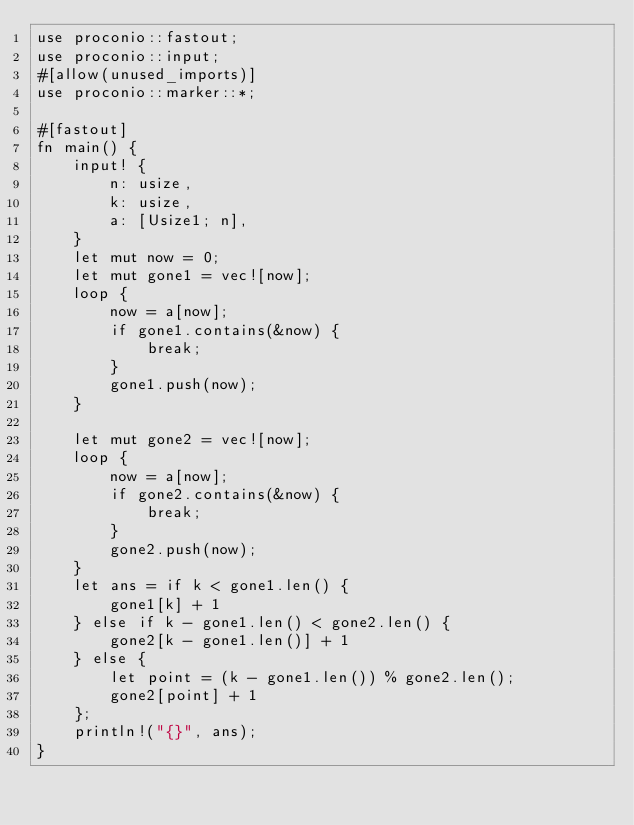<code> <loc_0><loc_0><loc_500><loc_500><_Rust_>use proconio::fastout;
use proconio::input;
#[allow(unused_imports)]
use proconio::marker::*;

#[fastout]
fn main() {
    input! {
        n: usize,
        k: usize,
        a: [Usize1; n],
    }
    let mut now = 0;
    let mut gone1 = vec![now];
    loop {
        now = a[now];
        if gone1.contains(&now) {
            break;
        }
        gone1.push(now);
    }

    let mut gone2 = vec![now];
    loop {
        now = a[now];
        if gone2.contains(&now) {
            break;
        }
        gone2.push(now);
    }
    let ans = if k < gone1.len() {
        gone1[k] + 1
    } else if k - gone1.len() < gone2.len() {
        gone2[k - gone1.len()] + 1
    } else {
        let point = (k - gone1.len()) % gone2.len();
        gone2[point] + 1
    };
    println!("{}", ans);
}
</code> 